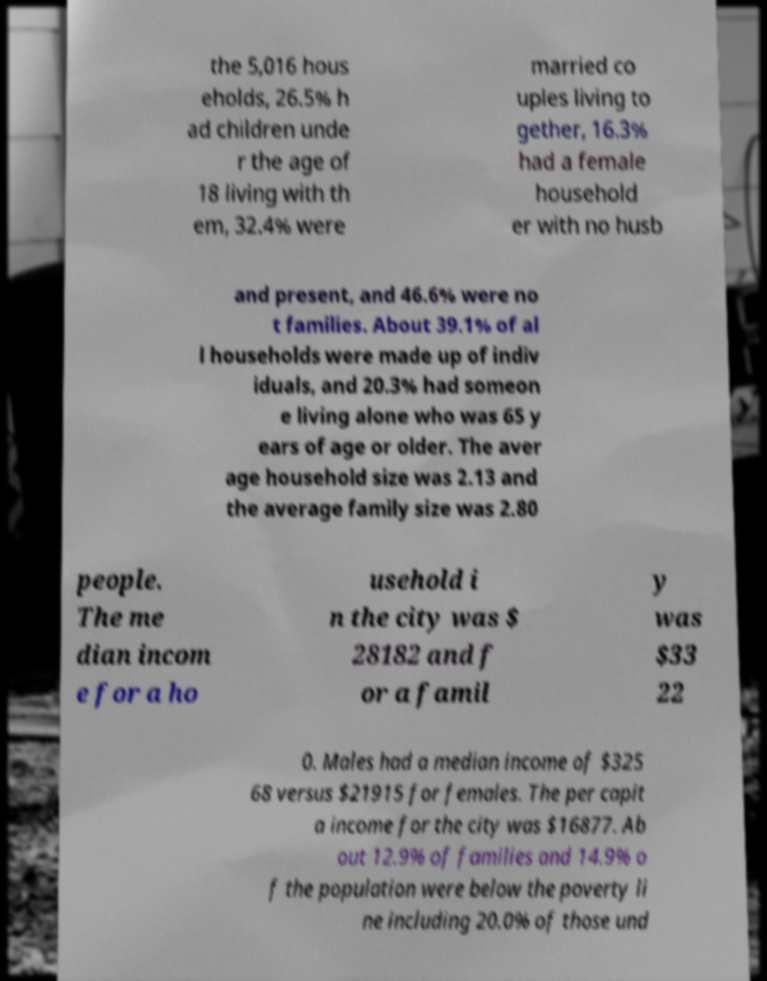There's text embedded in this image that I need extracted. Can you transcribe it verbatim? the 5,016 hous eholds, 26.5% h ad children unde r the age of 18 living with th em, 32.4% were married co uples living to gether, 16.3% had a female household er with no husb and present, and 46.6% were no t families. About 39.1% of al l households were made up of indiv iduals, and 20.3% had someon e living alone who was 65 y ears of age or older. The aver age household size was 2.13 and the average family size was 2.80 people. The me dian incom e for a ho usehold i n the city was $ 28182 and f or a famil y was $33 22 0. Males had a median income of $325 68 versus $21915 for females. The per capit a income for the city was $16877. Ab out 12.9% of families and 14.9% o f the population were below the poverty li ne including 20.0% of those und 